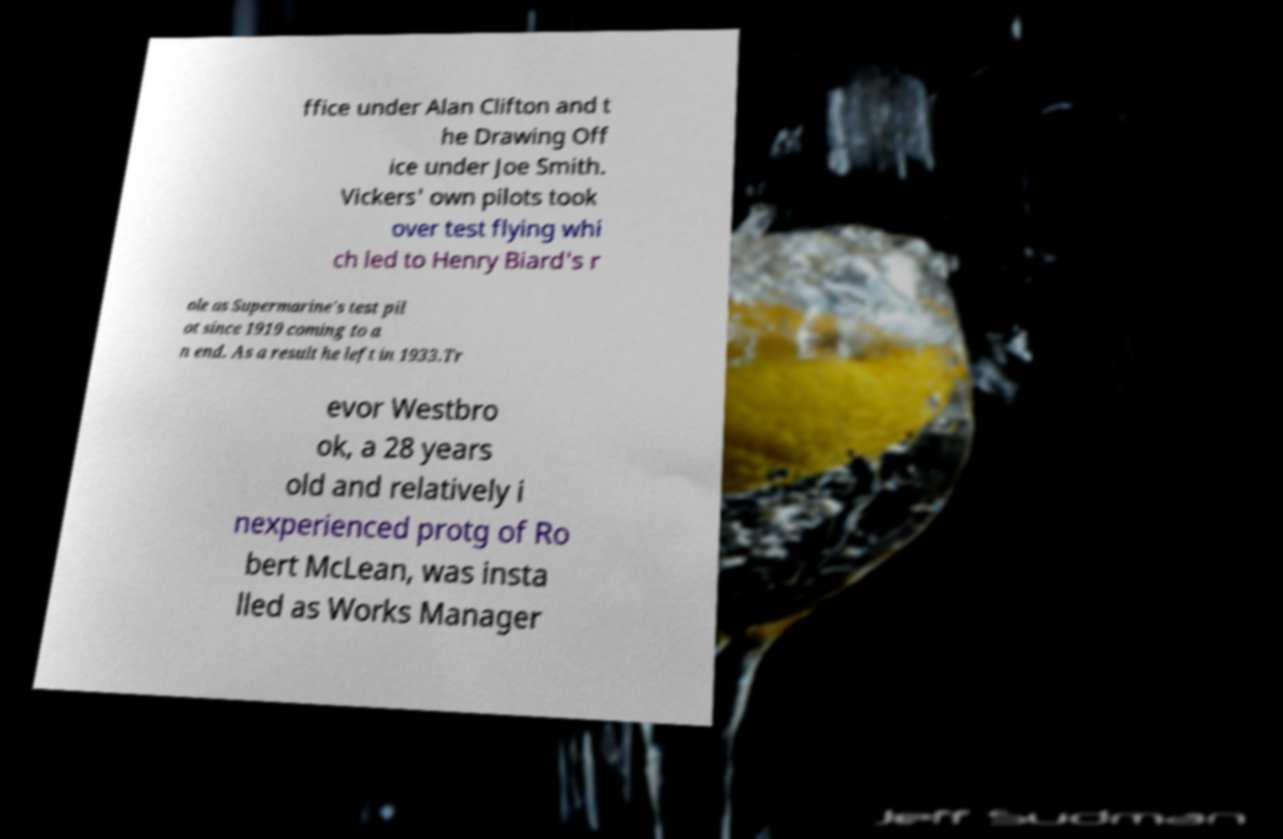Could you assist in decoding the text presented in this image and type it out clearly? ffice under Alan Clifton and t he Drawing Off ice under Joe Smith. Vickers' own pilots took over test flying whi ch led to Henry Biard's r ole as Supermarine's test pil ot since 1919 coming to a n end. As a result he left in 1933.Tr evor Westbro ok, a 28 years old and relatively i nexperienced protg of Ro bert McLean, was insta lled as Works Manager 